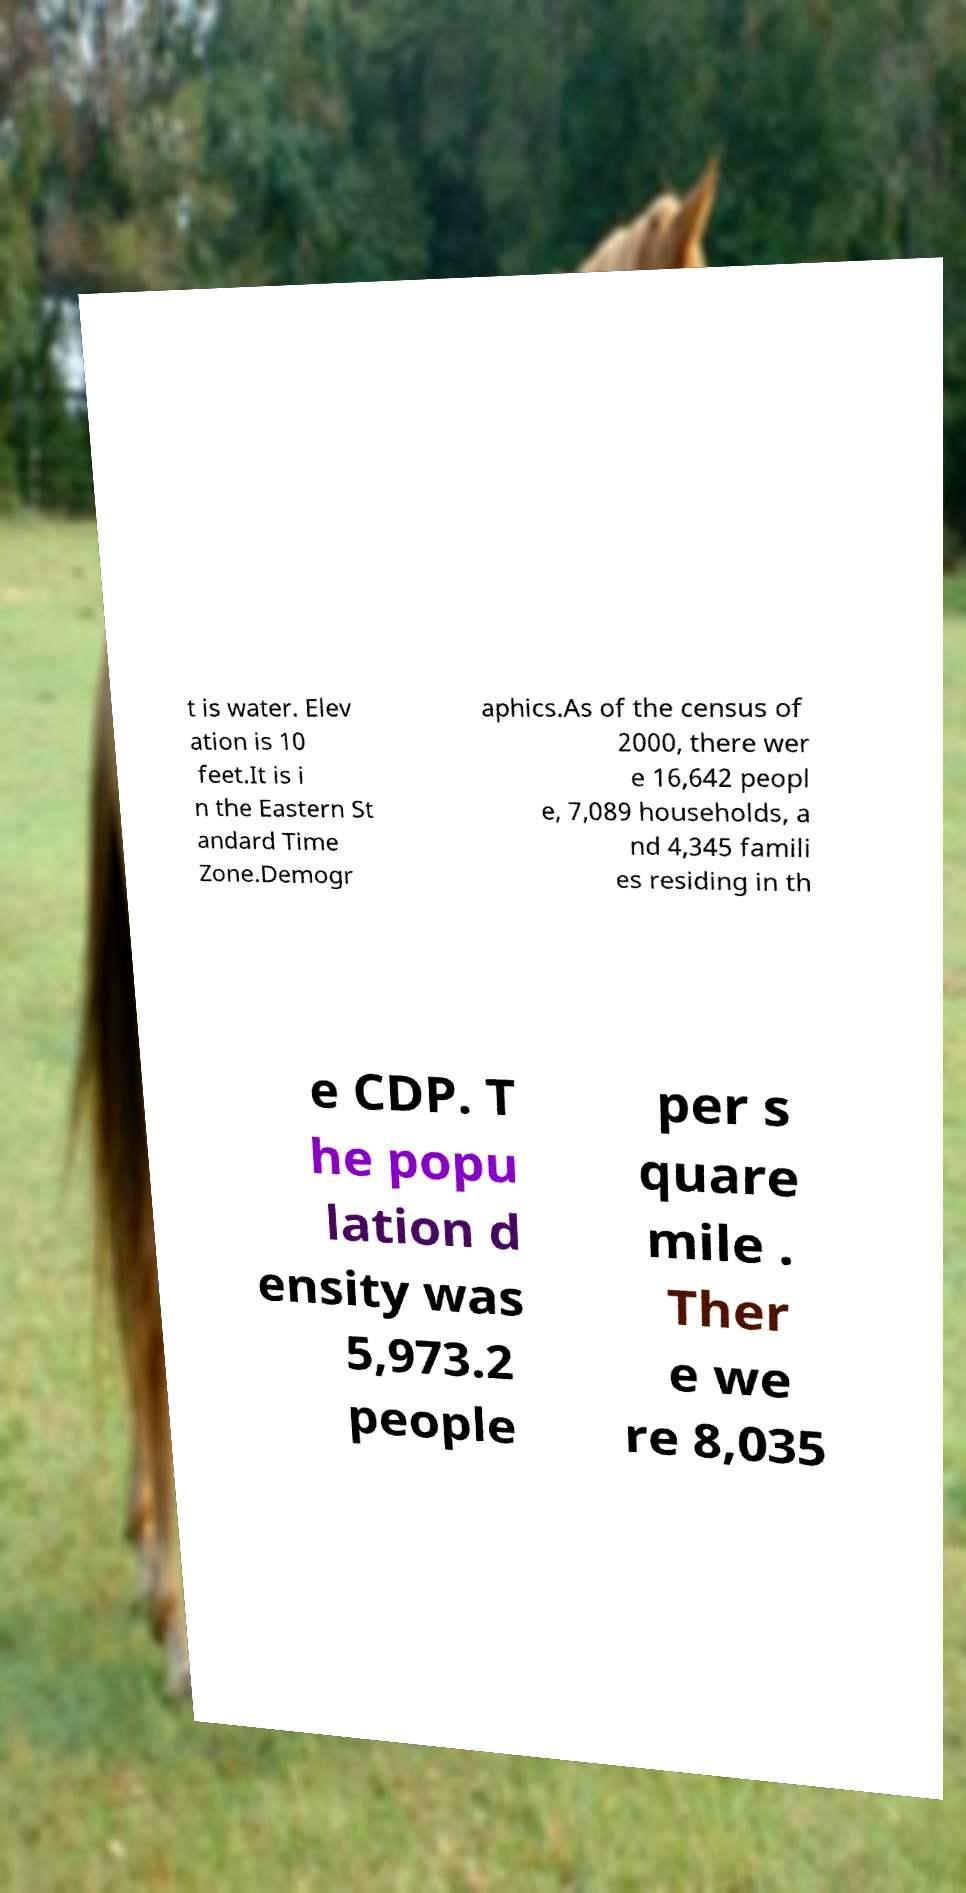Could you assist in decoding the text presented in this image and type it out clearly? t is water. Elev ation is 10 feet.It is i n the Eastern St andard Time Zone.Demogr aphics.As of the census of 2000, there wer e 16,642 peopl e, 7,089 households, a nd 4,345 famili es residing in th e CDP. T he popu lation d ensity was 5,973.2 people per s quare mile . Ther e we re 8,035 